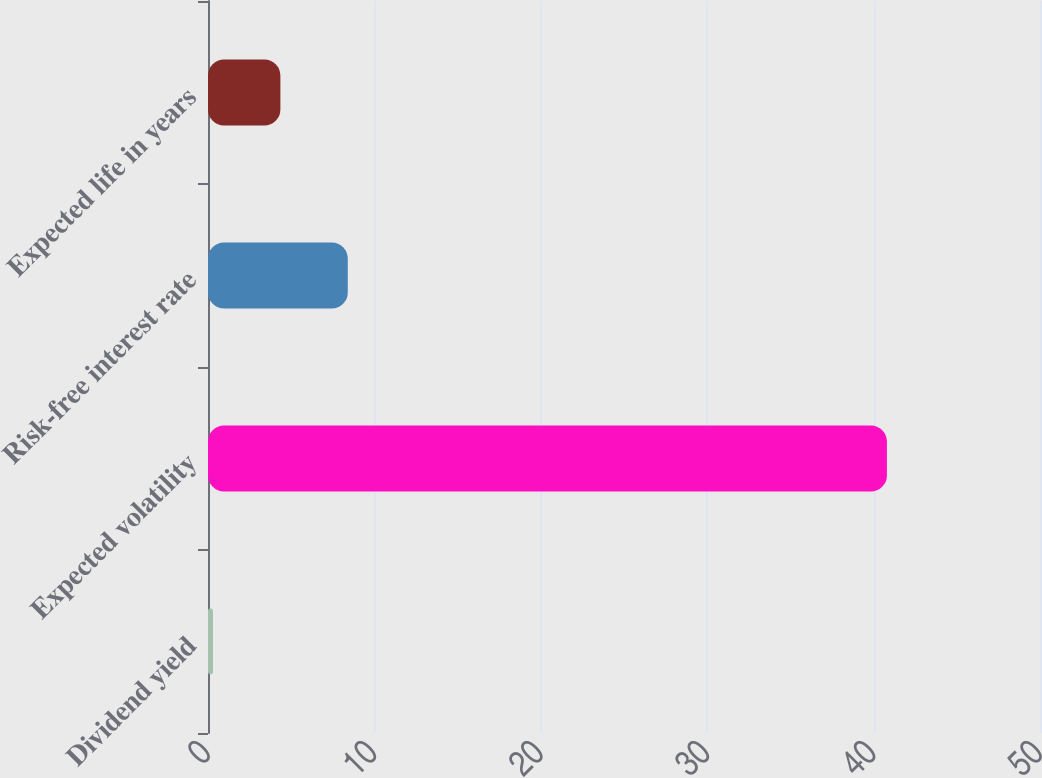Convert chart. <chart><loc_0><loc_0><loc_500><loc_500><bar_chart><fcel>Dividend yield<fcel>Expected volatility<fcel>Risk-free interest rate<fcel>Expected life in years<nl><fcel>0.3<fcel>40.8<fcel>8.4<fcel>4.35<nl></chart> 